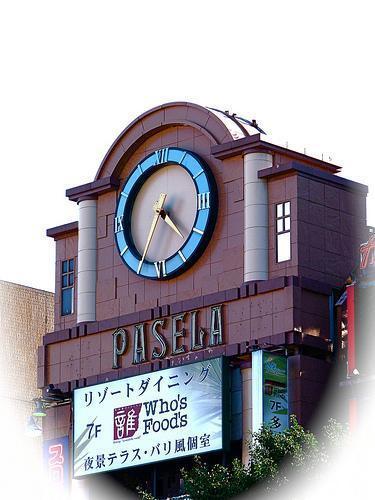How many languages are on white sign?
Give a very brief answer. 2. How many windows are in picture?
Give a very brief answer. 2. 